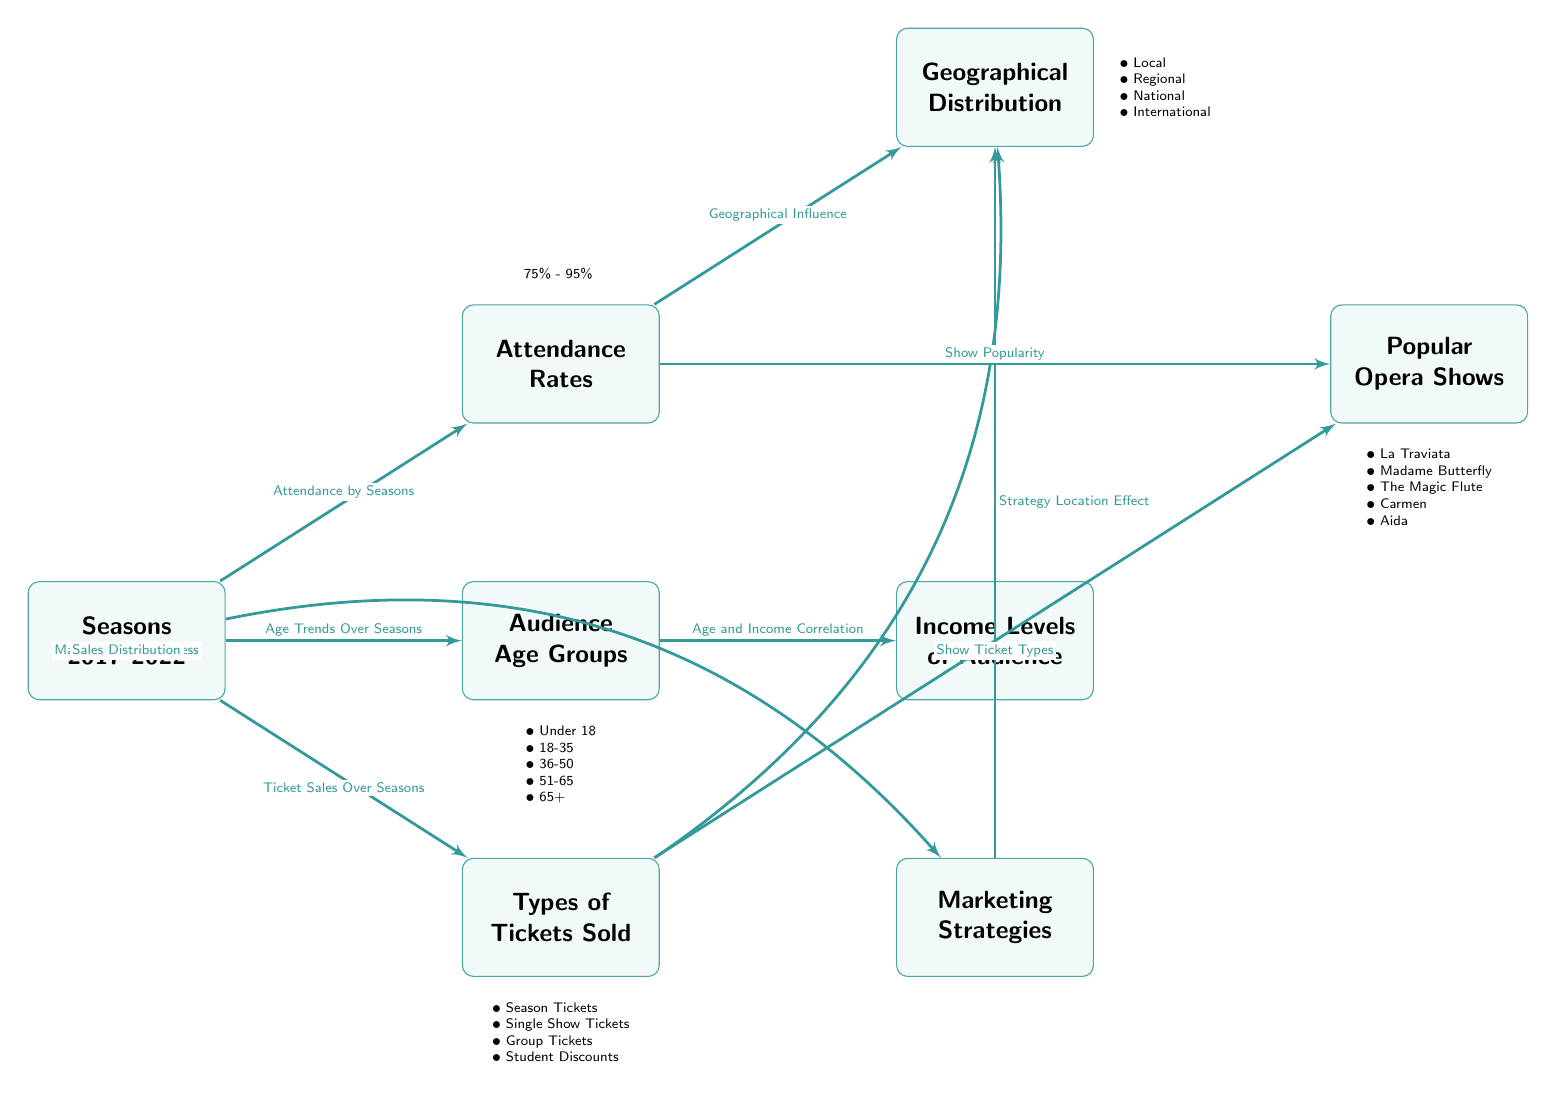What are the seasons covered in the diagram? The diagram mentions "Seasons 2017-2022," indicating the time frame under analysis.
Answer: Seasons 2017-2022 What are the different age groups represented in the audience? The age groups listed in the diagram are "Under 18," "18-35," "36-50," "51-65," and "65+." These groups categorize the audience demographics based on age.
Answer: Under 18, 18-35, 36-50, 51-65, 65+ What is the range of attendance rates indicated? The diagram specifies attendance rates between "75% - 95%," reflecting the percentage of audience attendance for performances.
Answer: 75% - 95% Which node discusses the correlation between age and income? The "Income Levels of Audience" node is connected to the "Audience Age Groups" node, indicating a relationship between these two aspects.
Answer: Income Levels of Audience How does geographical distribution influence attendance? The relationship between the "Attendance Rates" and "Geographical Distribution" nodes suggests that geographical factors have an impact on attendance rates.
Answer: Geographical Influence What types of tickets are identified in the diagram? The listed ticket types are "Season Tickets," "Single Show Tickets," "Group Tickets," and "Student Discounts," indicating the variations in ticket sales.
Answer: Season Tickets, Single Show Tickets, Group Tickets, Student Discounts Which opera shows are highlighted as popular in the diagram? The popular shows mentioned are "La Traviata," "Madame Butterfly," "The Magic Flute," "Carmen," and "Aida," showcasing the most attended performances.
Answer: La Traviata, Madame Butterfly, The Magic Flute, Carmen, Aida What influence do marketing strategies have according to the diagram? The connection between "Marketing Strategies" and "Geographical Distribution" indicates that marketing effectiveness varies by location, influencing audience turnout.
Answer: Strategy Location Effect What is the correlation between age and ticket sales? Looking at the linking edge from "Audience Age Groups" to "Types of Tickets Sold," it indicates there are variations in ticket sales based on the age group of the audience.
Answer: Age and Income Correlation 